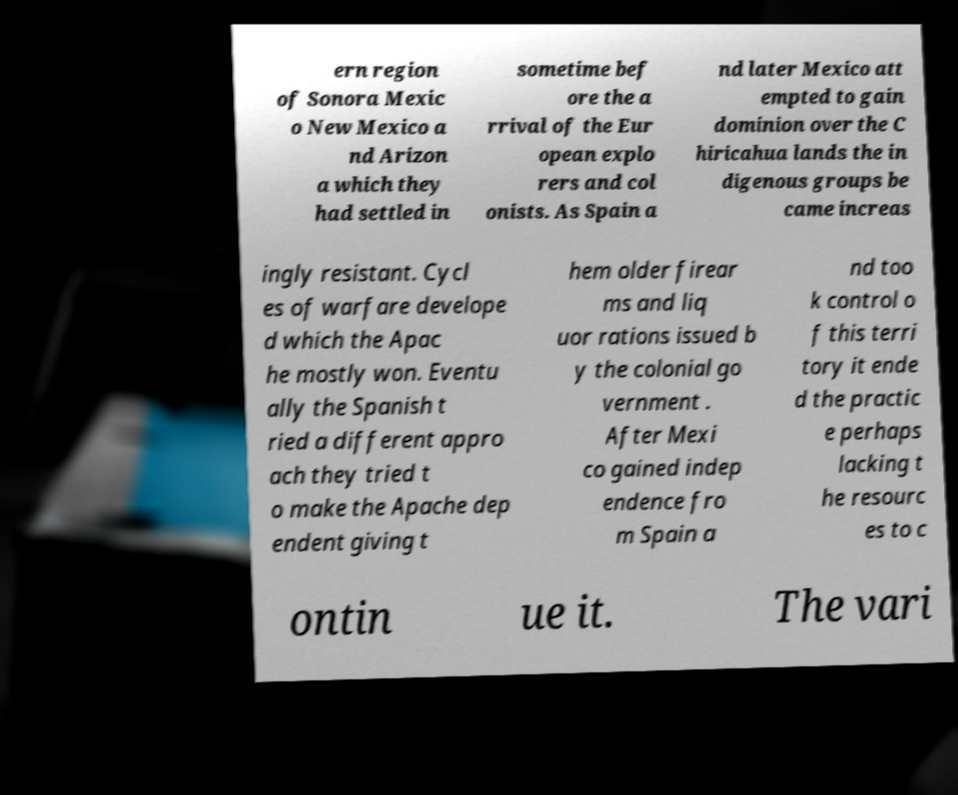There's text embedded in this image that I need extracted. Can you transcribe it verbatim? ern region of Sonora Mexic o New Mexico a nd Arizon a which they had settled in sometime bef ore the a rrival of the Eur opean explo rers and col onists. As Spain a nd later Mexico att empted to gain dominion over the C hiricahua lands the in digenous groups be came increas ingly resistant. Cycl es of warfare develope d which the Apac he mostly won. Eventu ally the Spanish t ried a different appro ach they tried t o make the Apache dep endent giving t hem older firear ms and liq uor rations issued b y the colonial go vernment . After Mexi co gained indep endence fro m Spain a nd too k control o f this terri tory it ende d the practic e perhaps lacking t he resourc es to c ontin ue it. The vari 